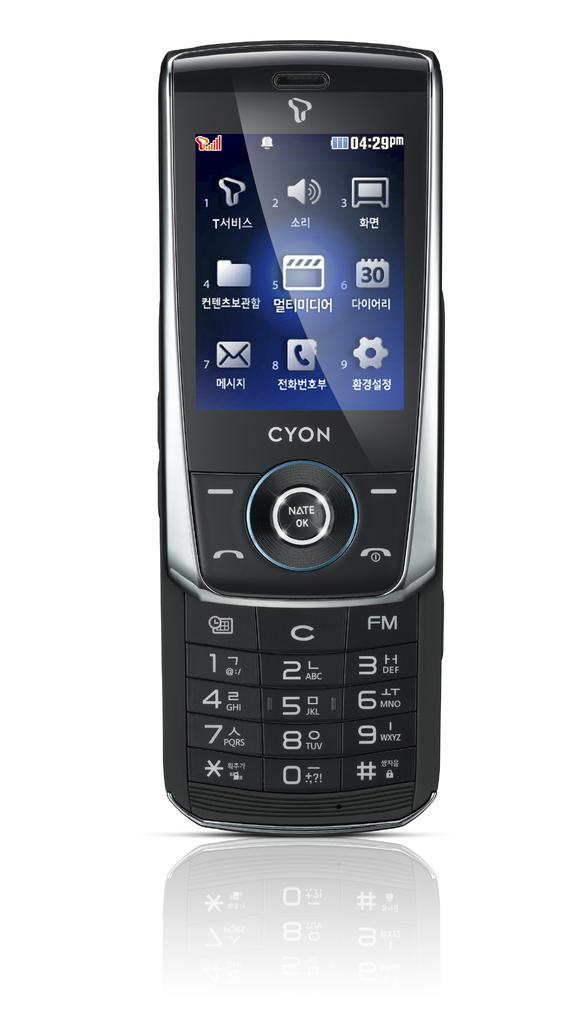<image>
Present a compact description of the photo's key features. A cell phone that slides up to reveal the number pad. 